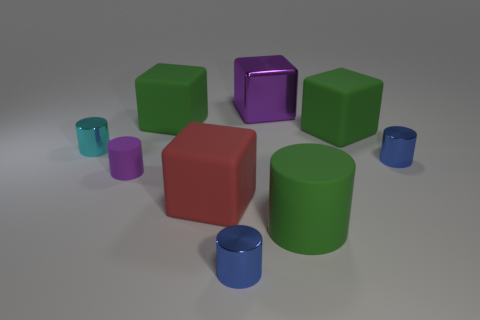There is a big cylinder that is made of the same material as the red block; what is its color?
Give a very brief answer. Green. How many objects are the same color as the small rubber cylinder?
Your answer should be very brief. 1. What number of things are either big cylinders or purple cubes?
Provide a succinct answer. 2. There is a red matte thing that is the same size as the purple metal thing; what is its shape?
Ensure brevity in your answer.  Cube. What number of tiny metallic objects are both to the right of the big red block and behind the big red rubber block?
Offer a terse response. 1. What is the cube that is right of the big purple block made of?
Offer a terse response. Rubber. There is a cyan object that is made of the same material as the big purple thing; what size is it?
Provide a succinct answer. Small. There is a blue metal object that is left of the big metallic cube; does it have the same size as the shiny cylinder to the left of the red rubber block?
Your answer should be very brief. Yes. What material is the green cylinder that is the same size as the metallic cube?
Give a very brief answer. Rubber. What is the large thing that is to the right of the big shiny object and behind the green cylinder made of?
Provide a succinct answer. Rubber. 